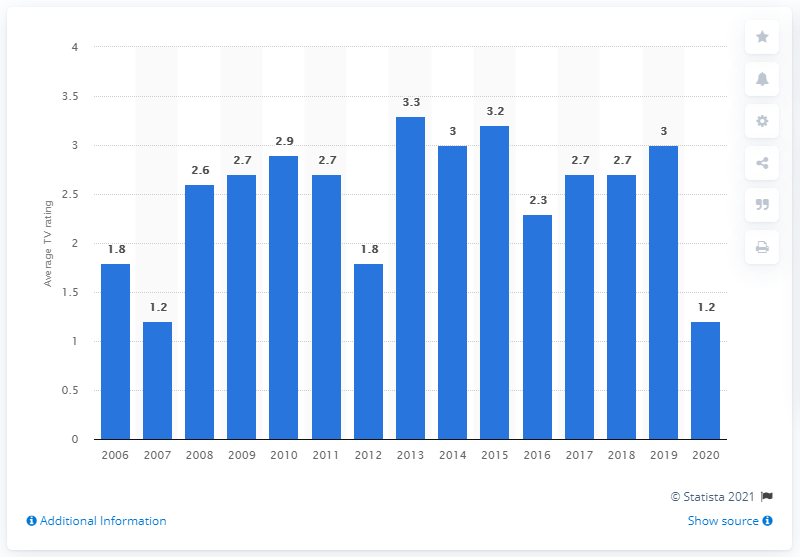Specify some key components in this picture. The average TV rating in the United States in 2020 was 1.2. 